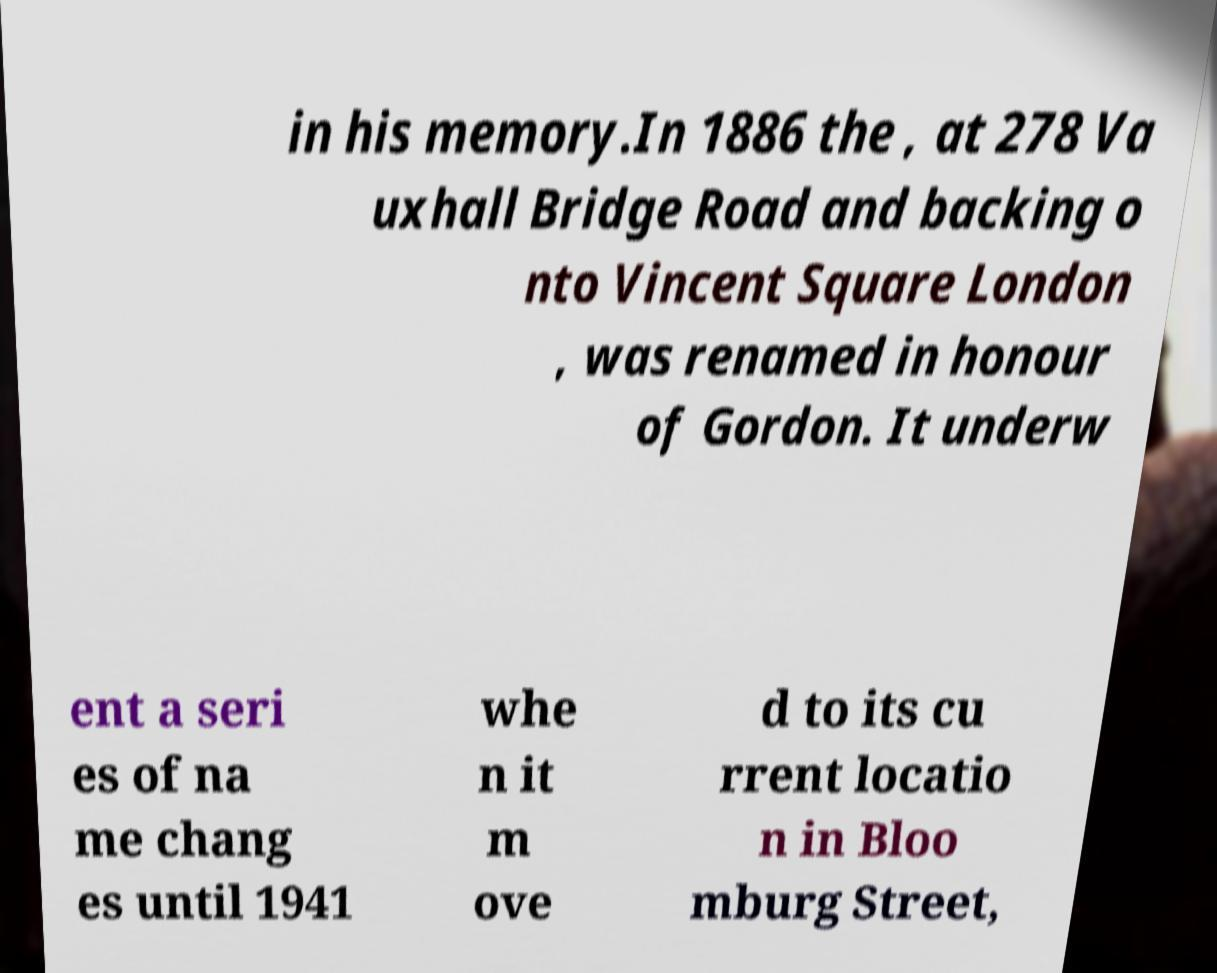For documentation purposes, I need the text within this image transcribed. Could you provide that? in his memory.In 1886 the , at 278 Va uxhall Bridge Road and backing o nto Vincent Square London , was renamed in honour of Gordon. It underw ent a seri es of na me chang es until 1941 whe n it m ove d to its cu rrent locatio n in Bloo mburg Street, 